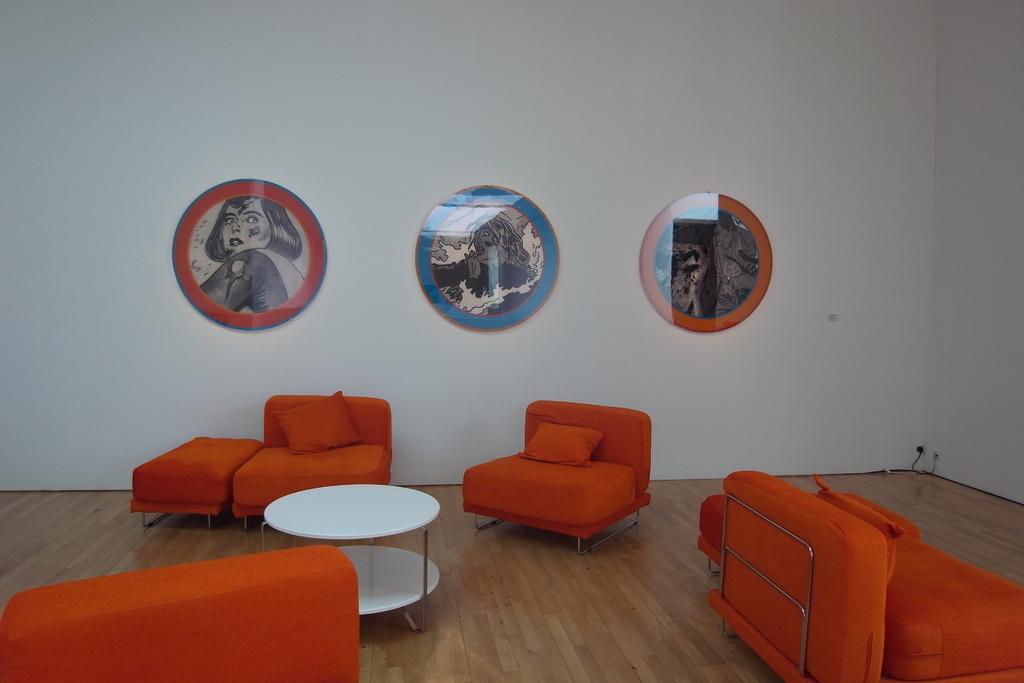How would you summarize this image in a sentence or two? There are sofa chairs in the room and a table photo frames on the wall. 